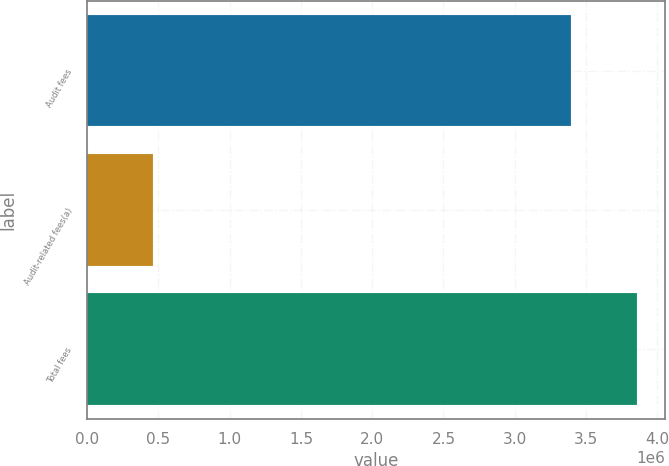Convert chart. <chart><loc_0><loc_0><loc_500><loc_500><bar_chart><fcel>Audit fees<fcel>Audit-related fees(a)<fcel>Total fees<nl><fcel>3.39828e+06<fcel>461960<fcel>3.86024e+06<nl></chart> 